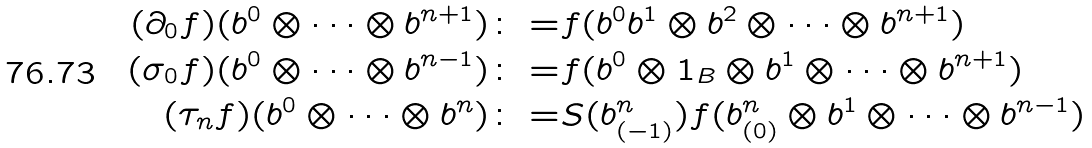<formula> <loc_0><loc_0><loc_500><loc_500>( \partial _ { 0 } f ) ( b ^ { 0 } \otimes \cdots \otimes b ^ { n + 1 } ) \colon = & f ( b ^ { 0 } b ^ { 1 } \otimes b ^ { 2 } \otimes \cdots \otimes b ^ { n + 1 } ) \\ ( \sigma _ { 0 } f ) ( b ^ { 0 } \otimes \cdots \otimes b ^ { n - 1 } ) \colon = & f ( b ^ { 0 } \otimes 1 _ { B } \otimes b ^ { 1 } \otimes \cdots \otimes b ^ { n + 1 } ) \\ ( \tau _ { n } f ) ( b ^ { 0 } \otimes \cdots \otimes b ^ { n } ) \colon = & S ( b ^ { n } _ { ( - 1 ) } ) f ( b ^ { n } _ { ( 0 ) } \otimes b ^ { 1 } \otimes \cdots \otimes b ^ { n - 1 } )</formula> 